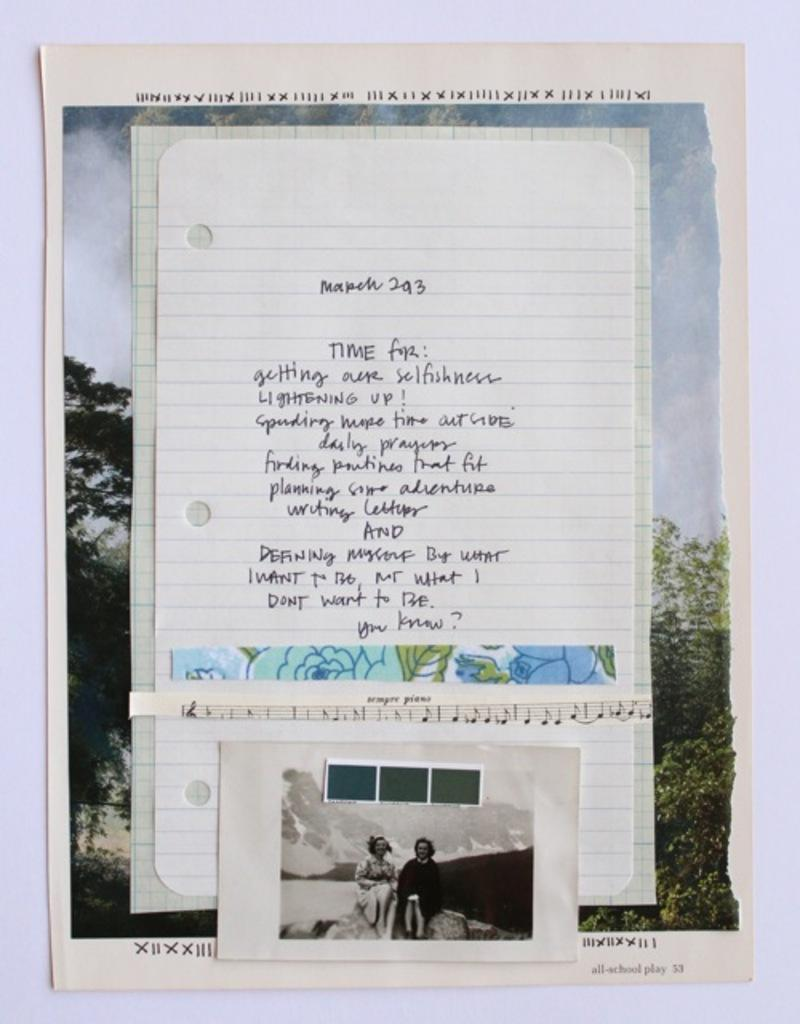<image>
Give a short and clear explanation of the subsequent image. a sheet of paper that says 'time for:' on it 